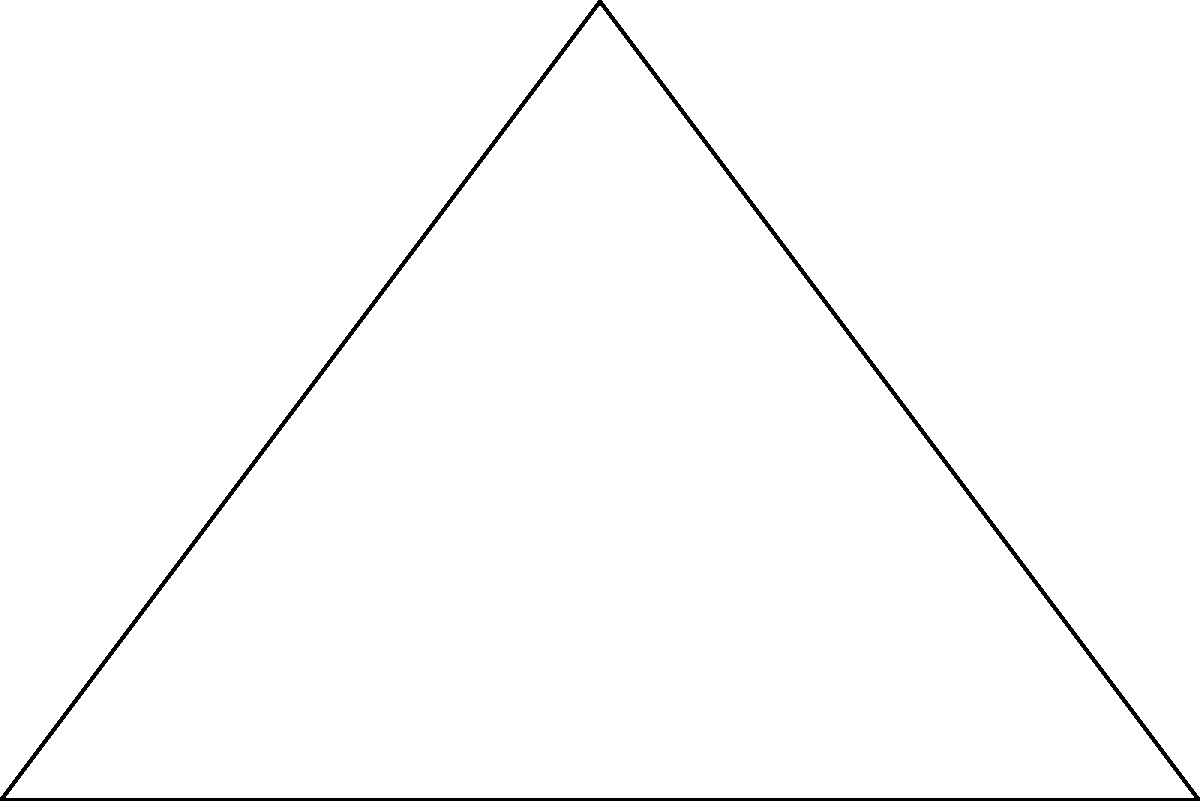A luxury resort in Dubai is planning to build on a triangular plot of land. The plot has a base of 6 km and a height of 4 km. What is the area of this triangular plot in square kilometers? To find the area of a triangular plot, we can use the formula:

$$A = \frac{1}{2} \times base \times height$$

Given:
- Base of the triangle = 6 km
- Height of the triangle = 4 km

Let's substitute these values into the formula:

$$\begin{align}
A &= \frac{1}{2} \times 6 \times 4 \\
&= \frac{1}{2} \times 24 \\
&= 12
\end{align}$$

Therefore, the area of the triangular plot is 12 square kilometers.
Answer: 12 sq km 